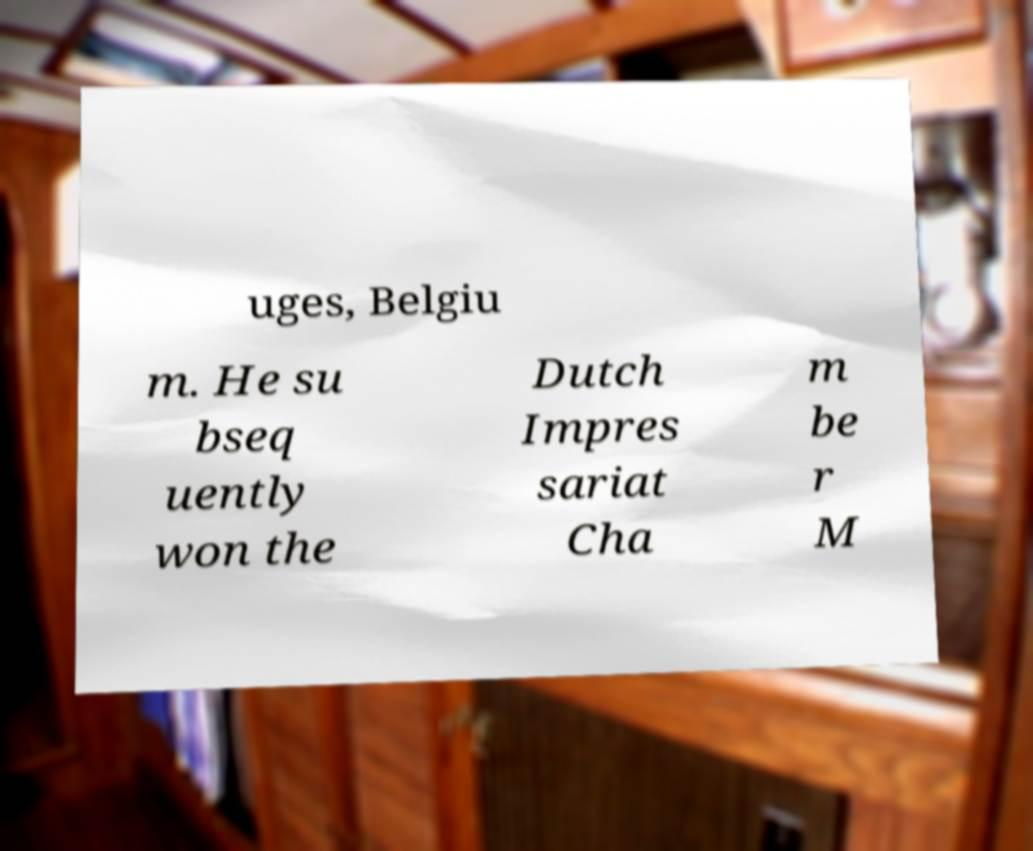Can you read and provide the text displayed in the image?This photo seems to have some interesting text. Can you extract and type it out for me? uges, Belgiu m. He su bseq uently won the Dutch Impres sariat Cha m be r M 